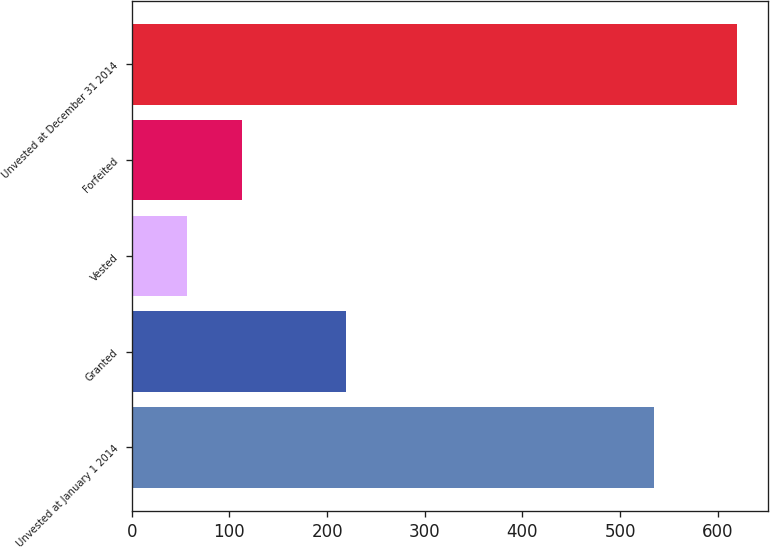Convert chart to OTSL. <chart><loc_0><loc_0><loc_500><loc_500><bar_chart><fcel>Unvested at January 1 2014<fcel>Granted<fcel>Vested<fcel>Forfeited<fcel>Unvested at December 31 2014<nl><fcel>535<fcel>219<fcel>57<fcel>113.3<fcel>620<nl></chart> 